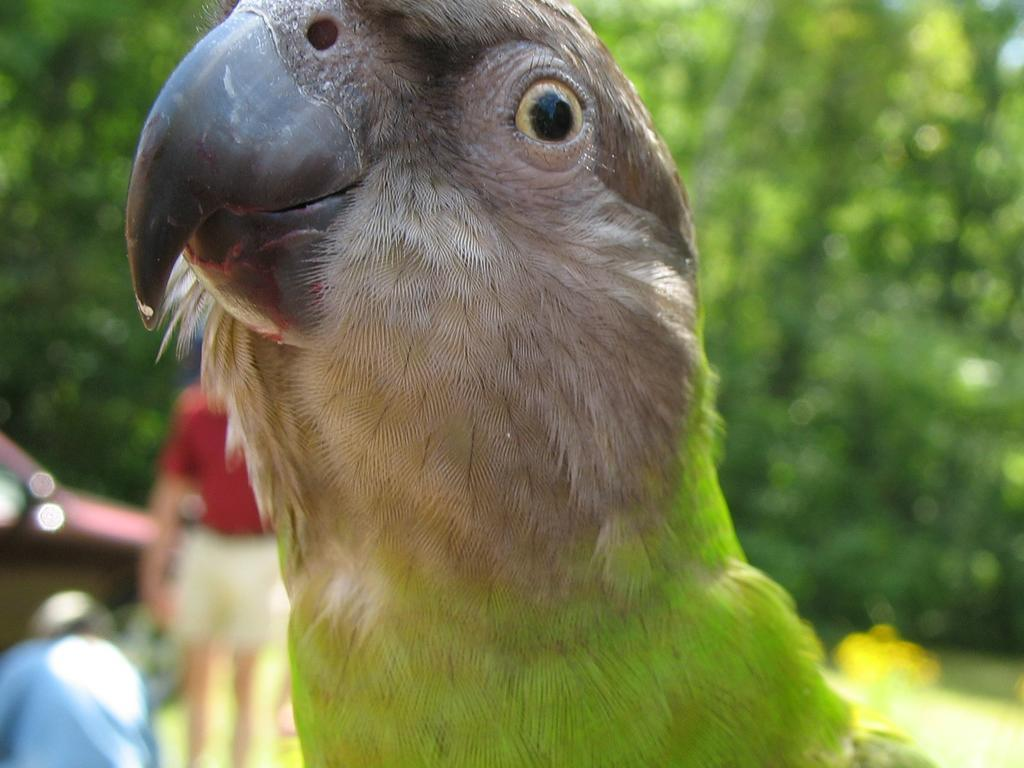What is the main subject in the foreground of the image? There is a bird in the foreground of the image. What can be seen in the background of the image? There is a car, two persons, and trees in the background of the image. What type of government is depicted in the image? There is no depiction of a government in the image; it features a bird in the foreground and various background elements. What kind of music can be heard in the image? There is no audio component in the image, so it is not possible to determine what kind of music might be heard. 